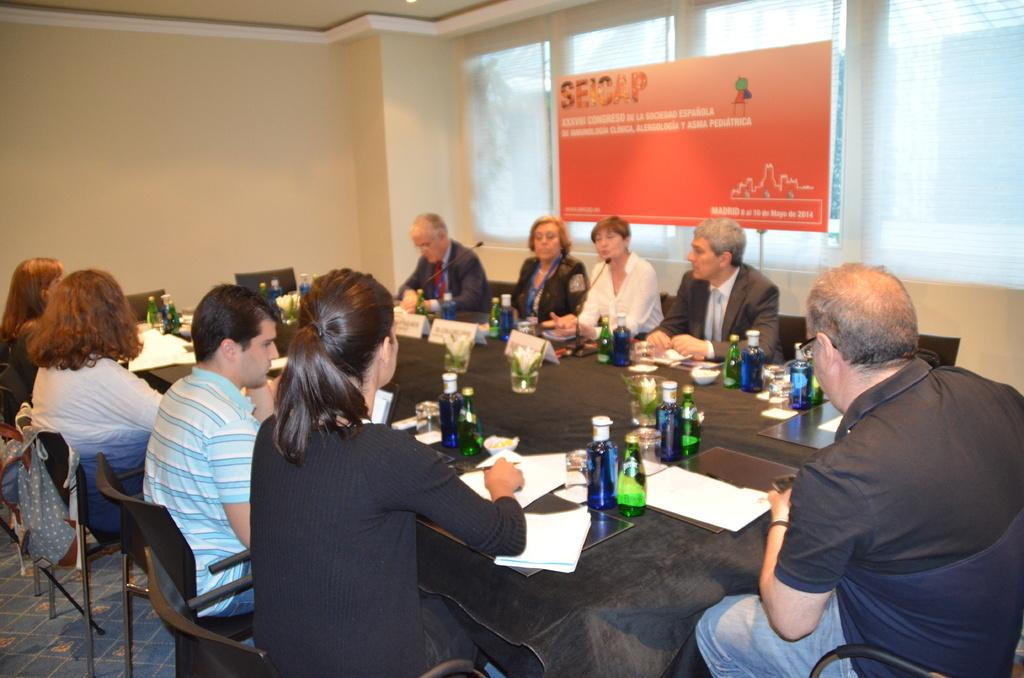What are the people in the image doing? The people in the image are sitting on chairs at a table. What objects can be seen on the table? There are bottles, glasses, papers, and microphones on the table. What can be seen in the background of the image? There is a wall, a window, and a hoarding in the background. What type of lock can be seen on the car in the image? There is no car present in the image, so there is no lock to be seen. What is the friction between the microphones on the table? The question about friction is not relevant to the image, as it does not involve any movement or interaction between the microphones. 